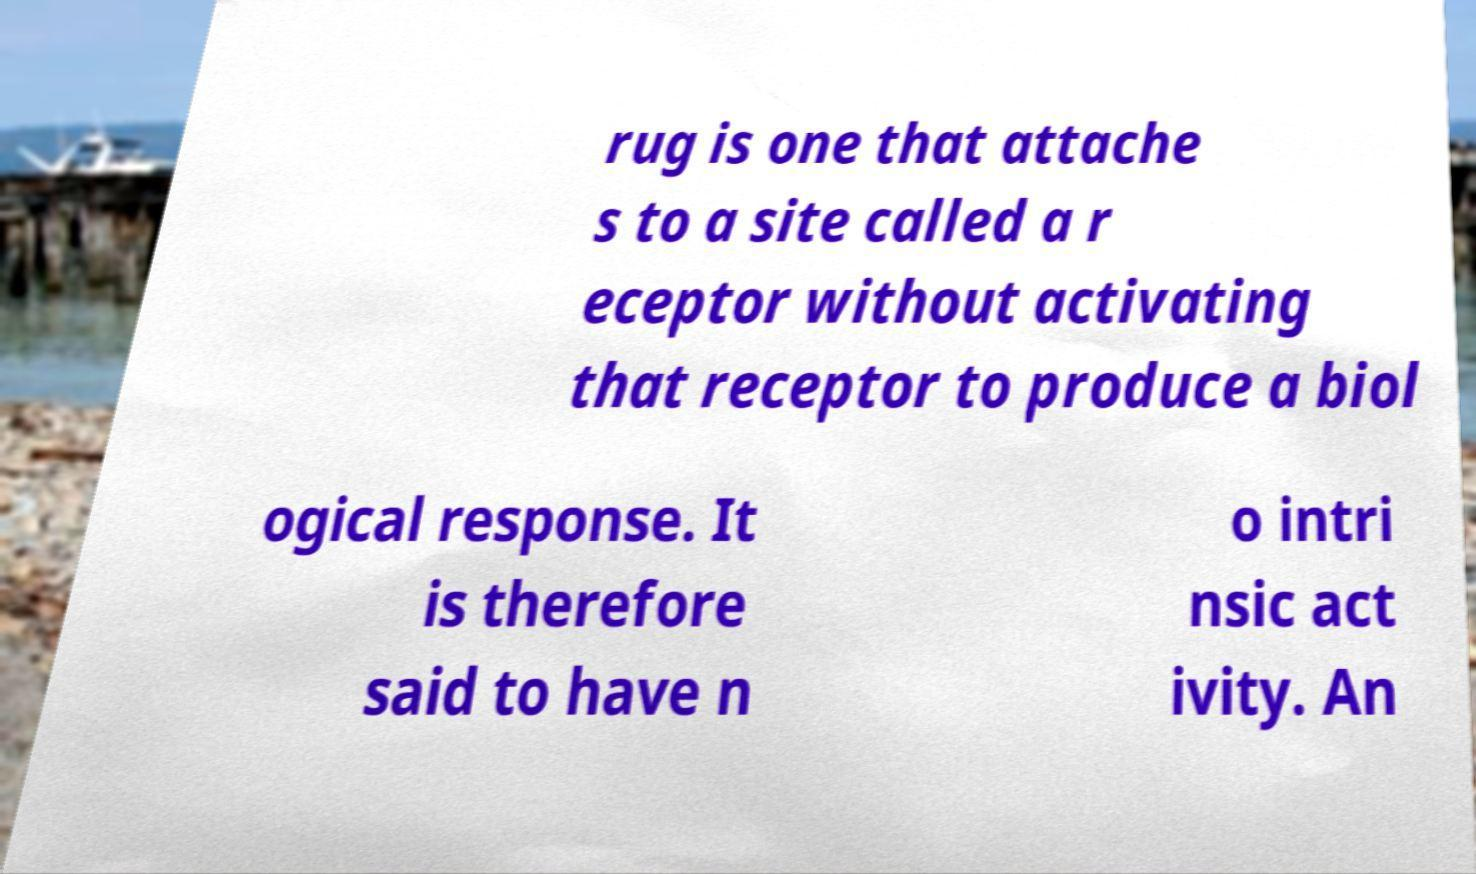There's text embedded in this image that I need extracted. Can you transcribe it verbatim? rug is one that attache s to a site called a r eceptor without activating that receptor to produce a biol ogical response. It is therefore said to have n o intri nsic act ivity. An 